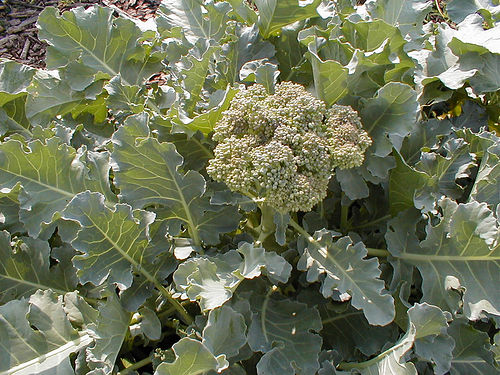<image>What type of plants are these? I am not sure about the type of plants. It could be broccoli or bushes. What type of plants are these? I don't know what type of plants these are. They can be broccoli or bushes. 